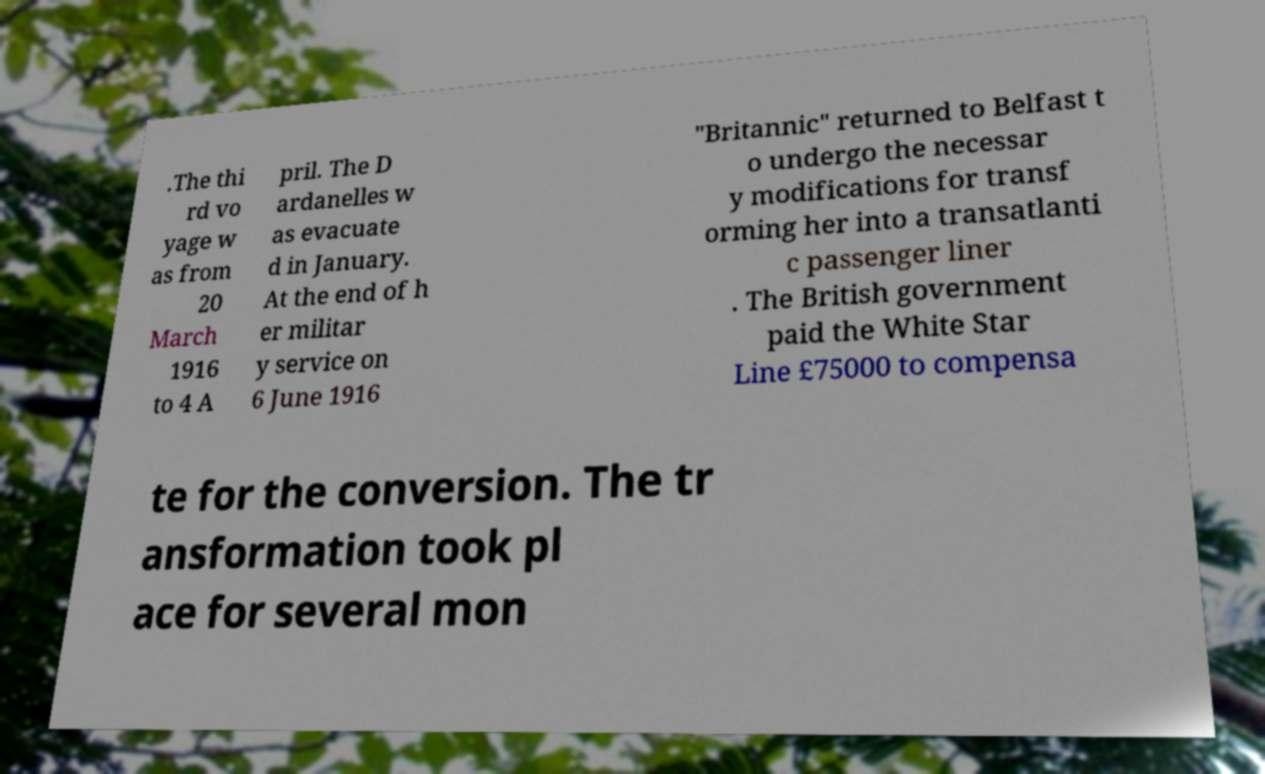For documentation purposes, I need the text within this image transcribed. Could you provide that? .The thi rd vo yage w as from 20 March 1916 to 4 A pril. The D ardanelles w as evacuate d in January. At the end of h er militar y service on 6 June 1916 "Britannic" returned to Belfast t o undergo the necessar y modifications for transf orming her into a transatlanti c passenger liner . The British government paid the White Star Line £75000 to compensa te for the conversion. The tr ansformation took pl ace for several mon 